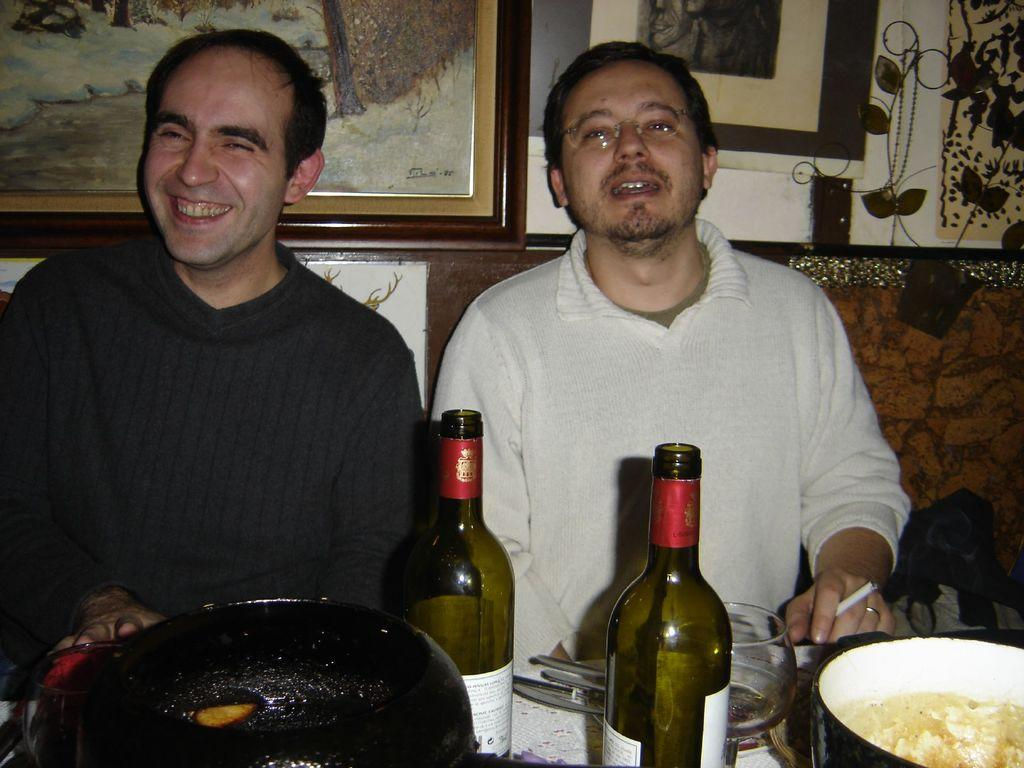What objects can be seen in the image that are used for displaying photos? There are photo frames in the image. What type of furniture can be seen in the image that people might sit on? There are two people sitting on a sofa in the image. What piece of furniture is present in the image that might be used for placing items? There is a table in the image. What type of dishware can be seen on the table in the image? There are bowls on the table in the image. What type of drinking vessels can be seen on the table in the image? There are glasses on the table in the image. What type of container can be seen on the table in the image that might hold a liquid? There is a bottle on the table in the image. What type of toy can be seen on the table in the image? There is no toy present on the table in the image. What season is depicted in the image, given the presence of summer clothing? The provided facts do not mention any clothing or seasons, so it cannot be determined from the image. 